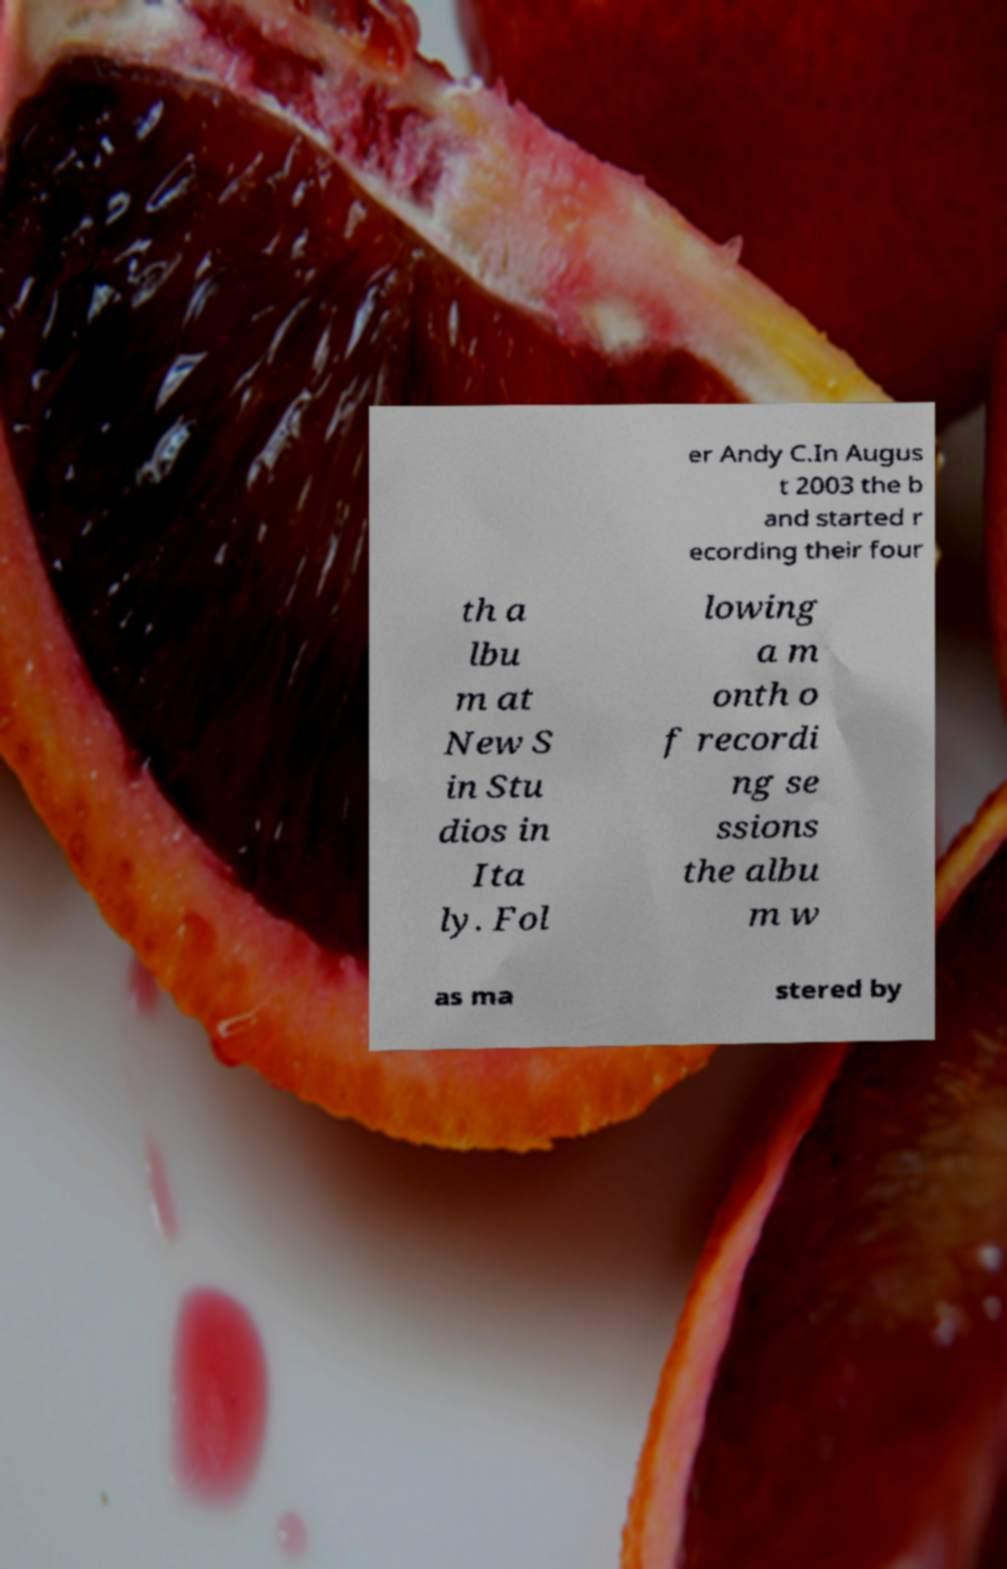What messages or text are displayed in this image? I need them in a readable, typed format. er Andy C.In Augus t 2003 the b and started r ecording their four th a lbu m at New S in Stu dios in Ita ly. Fol lowing a m onth o f recordi ng se ssions the albu m w as ma stered by 